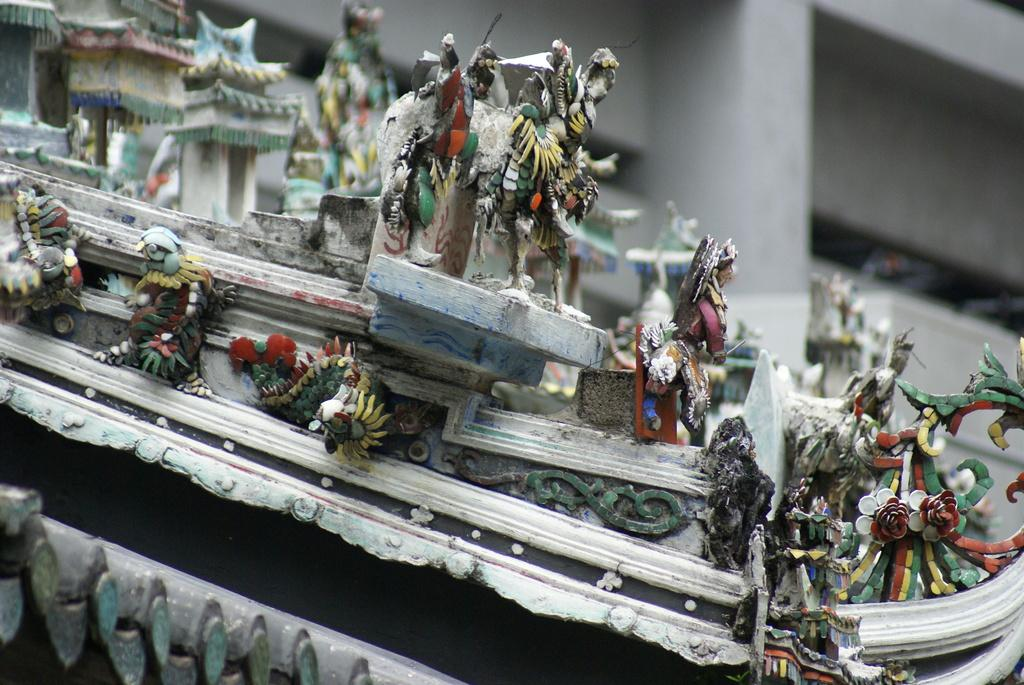What type of objects are present in the image? There are showpieces in the image. What type of punishment is being given to the ground in the image? There is no mention of punishment or the ground in the image; it only features showpieces. 